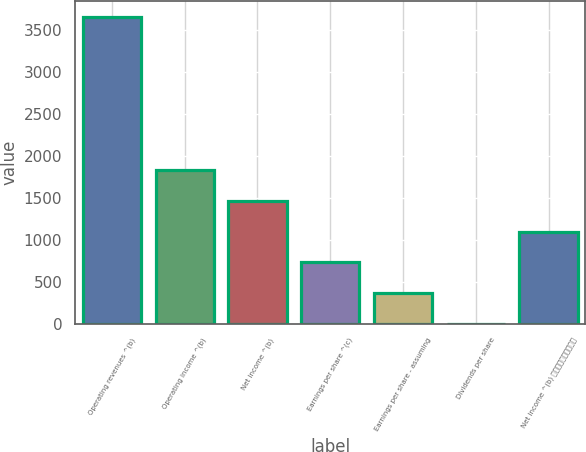<chart> <loc_0><loc_0><loc_500><loc_500><bar_chart><fcel>Operating revenues ^(b)<fcel>Operating income ^(b)<fcel>Net income ^(b)<fcel>Earnings per share ^(c)<fcel>Earnings per share - assuming<fcel>Dividends per share<fcel>Net income ^(b) ⎯⎯⎯⎯⎯⎯⎯⎯⎯⎯<nl><fcel>3655<fcel>1827.72<fcel>1462.27<fcel>731.37<fcel>365.92<fcel>0.47<fcel>1096.82<nl></chart> 